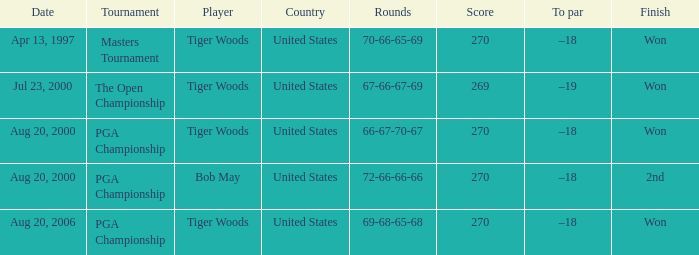What is the worst (highest) score? 270.0. Would you mind parsing the complete table? {'header': ['Date', 'Tournament', 'Player', 'Country', 'Rounds', 'Score', 'To par', 'Finish'], 'rows': [['Apr 13, 1997', 'Masters Tournament', 'Tiger Woods', 'United States', '70-66-65-69', '270', '–18', 'Won'], ['Jul 23, 2000', 'The Open Championship', 'Tiger Woods', 'United States', '67-66-67-69', '269', '–19', 'Won'], ['Aug 20, 2000', 'PGA Championship', 'Tiger Woods', 'United States', '66-67-70-67', '270', '–18', 'Won'], ['Aug 20, 2000', 'PGA Championship', 'Bob May', 'United States', '72-66-66-66', '270', '–18', '2nd'], ['Aug 20, 2006', 'PGA Championship', 'Tiger Woods', 'United States', '69-68-65-68', '270', '–18', 'Won']]} 